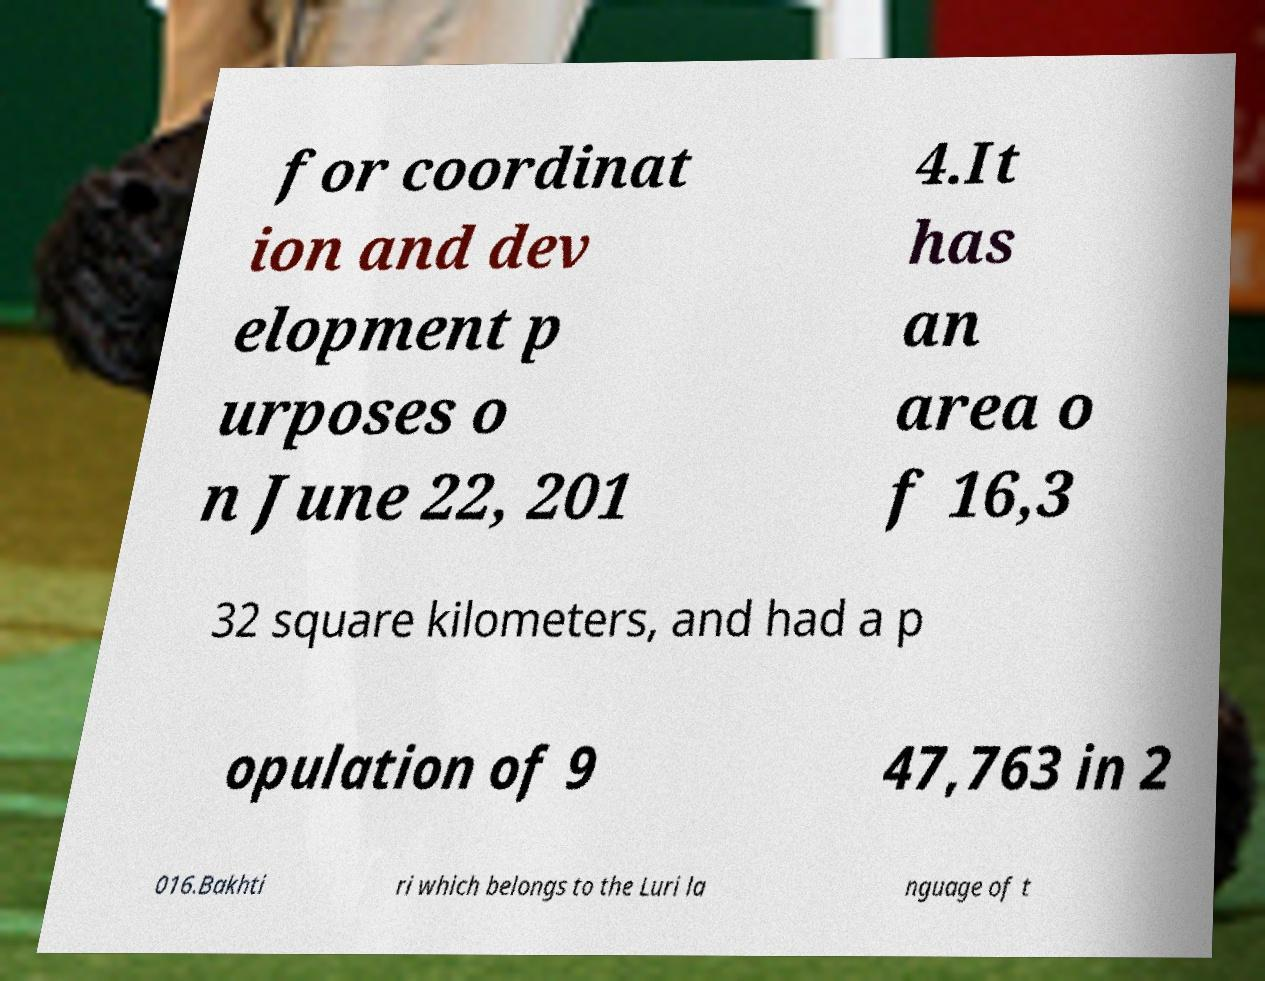There's text embedded in this image that I need extracted. Can you transcribe it verbatim? for coordinat ion and dev elopment p urposes o n June 22, 201 4.It has an area o f 16,3 32 square kilometers, and had a p opulation of 9 47,763 in 2 016.Bakhti ri which belongs to the Luri la nguage of t 